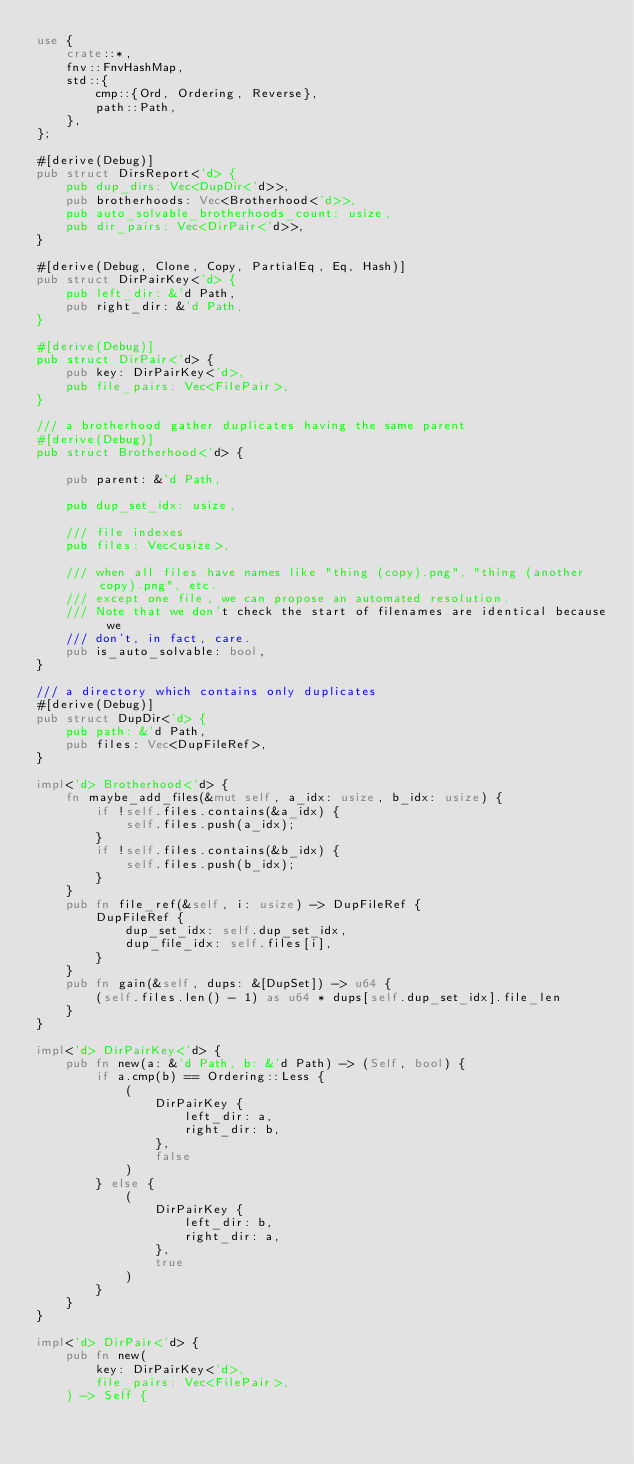<code> <loc_0><loc_0><loc_500><loc_500><_Rust_>use {
    crate::*,
    fnv::FnvHashMap,
    std::{
        cmp::{Ord, Ordering, Reverse},
        path::Path,
    },
};

#[derive(Debug)]
pub struct DirsReport<'d> {
    pub dup_dirs: Vec<DupDir<'d>>,
    pub brotherhoods: Vec<Brotherhood<'d>>,
    pub auto_solvable_brotherhoods_count: usize,
    pub dir_pairs: Vec<DirPair<'d>>,
}

#[derive(Debug, Clone, Copy, PartialEq, Eq, Hash)]
pub struct DirPairKey<'d> {
    pub left_dir: &'d Path,
    pub right_dir: &'d Path,
}

#[derive(Debug)]
pub struct DirPair<'d> {
    pub key: DirPairKey<'d>,
    pub file_pairs: Vec<FilePair>,
}

/// a brotherhood gather duplicates having the same parent
#[derive(Debug)]
pub struct Brotherhood<'d> {

    pub parent: &'d Path,

    pub dup_set_idx: usize,

    /// file indexes
    pub files: Vec<usize>,

    /// when all files have names like "thing (copy).png", "thing (another copy).png", etc.
    /// except one file, we can propose an automated resolution.
    /// Note that we don't check the start of filenames are identical because we
    /// don't, in fact, care.
    pub is_auto_solvable: bool,
}

/// a directory which contains only duplicates
#[derive(Debug)]
pub struct DupDir<'d> {
    pub path: &'d Path,
    pub files: Vec<DupFileRef>,
}

impl<'d> Brotherhood<'d> {
    fn maybe_add_files(&mut self, a_idx: usize, b_idx: usize) {
        if !self.files.contains(&a_idx) {
            self.files.push(a_idx);
        }
        if !self.files.contains(&b_idx) {
            self.files.push(b_idx);
        }
    }
    pub fn file_ref(&self, i: usize) -> DupFileRef {
        DupFileRef {
            dup_set_idx: self.dup_set_idx,
            dup_file_idx: self.files[i],
        }
    }
    pub fn gain(&self, dups: &[DupSet]) -> u64 {
        (self.files.len() - 1) as u64 * dups[self.dup_set_idx].file_len
    }
}

impl<'d> DirPairKey<'d> {
    pub fn new(a: &'d Path, b: &'d Path) -> (Self, bool) {
        if a.cmp(b) == Ordering::Less {
            (
                DirPairKey {
                    left_dir: a,
                    right_dir: b,
                },
                false
            )
        } else {
            (
                DirPairKey {
                    left_dir: b,
                    right_dir: a,
                },
                true
            )
        }
    }
}

impl<'d> DirPair<'d> {
    pub fn new(
        key: DirPairKey<'d>,
        file_pairs: Vec<FilePair>,
    ) -> Self {</code> 